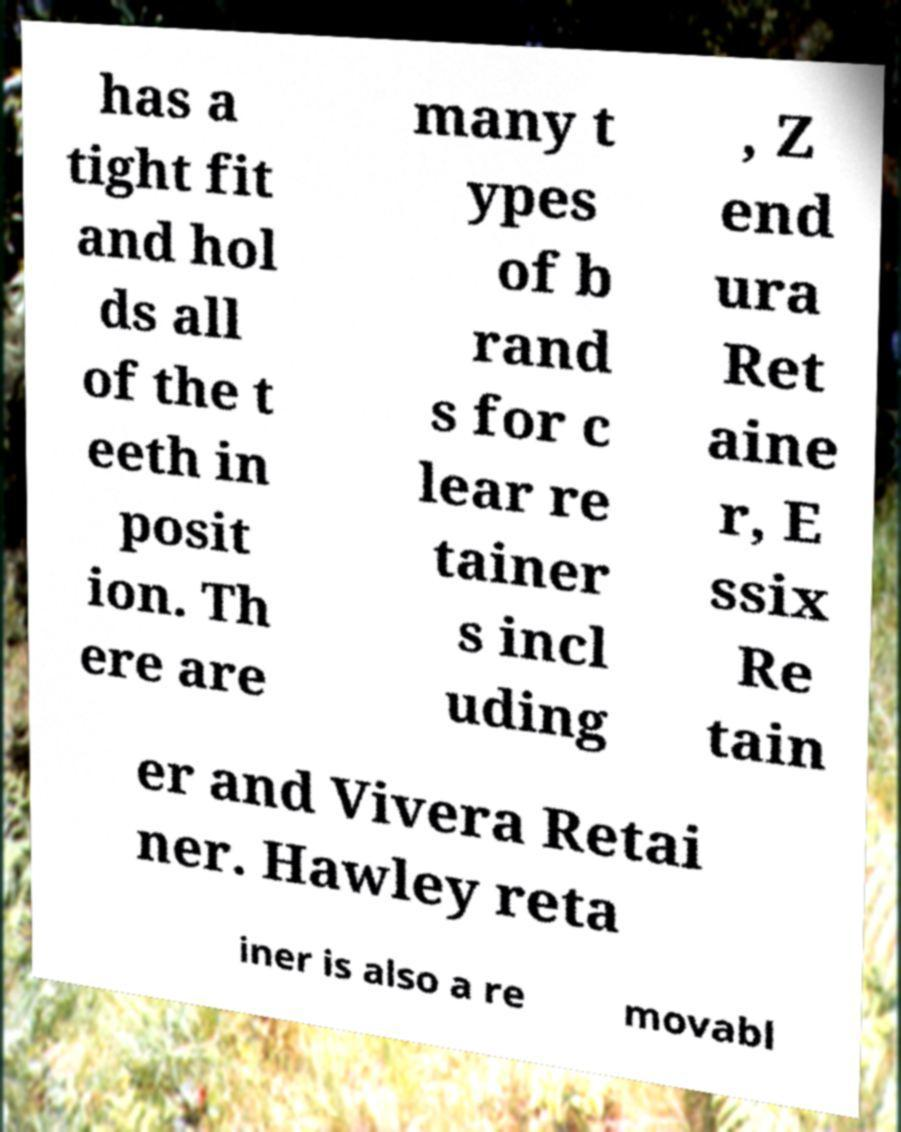Please read and relay the text visible in this image. What does it say? has a tight fit and hol ds all of the t eeth in posit ion. Th ere are many t ypes of b rand s for c lear re tainer s incl uding , Z end ura Ret aine r, E ssix Re tain er and Vivera Retai ner. Hawley reta iner is also a re movabl 